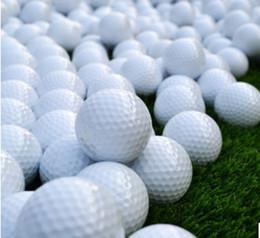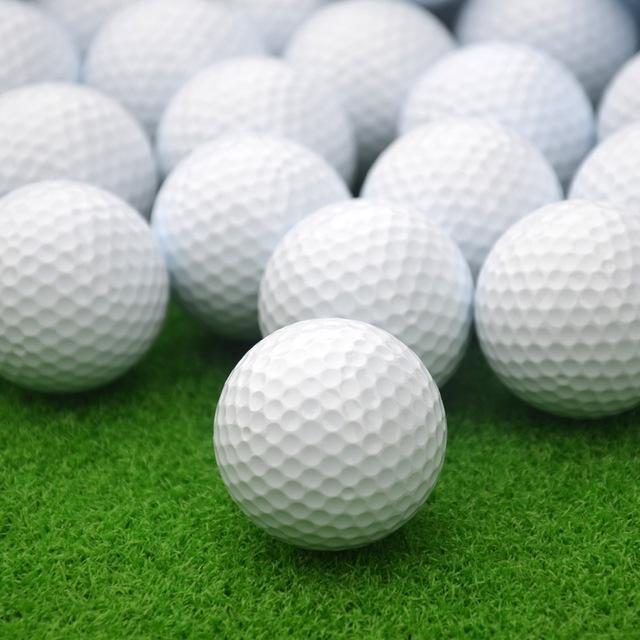The first image is the image on the left, the second image is the image on the right. Evaluate the accuracy of this statement regarding the images: "Both images show only white balls on green turf, with no logos or other markings on them.". Is it true? Answer yes or no. Yes. The first image is the image on the left, the second image is the image on the right. Examine the images to the left and right. Is the description "Lettering is visible on some of the golf balls in one of the images." accurate? Answer yes or no. No. 